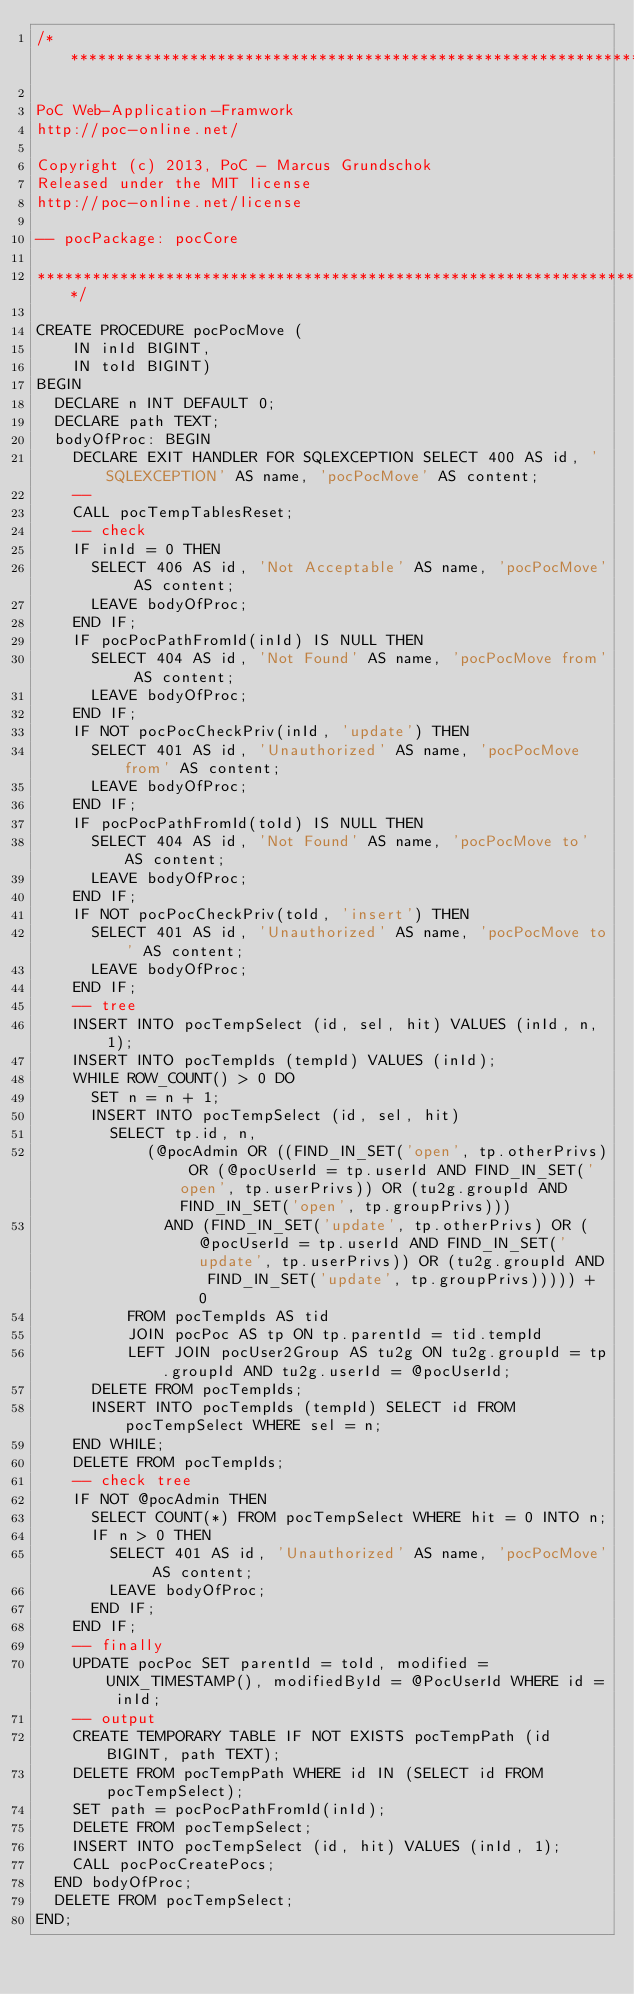Convert code to text. <code><loc_0><loc_0><loc_500><loc_500><_SQL_>/*******************************************************************************

PoC Web-Application-Framwork
http://poc-online.net/

Copyright (c) 2013, PoC - Marcus Grundschok
Released under the MIT license
http://poc-online.net/license

-- pocPackage: pocCore

*******************************************************************************/

CREATE PROCEDURE pocPocMove (
    IN inId BIGINT,
    IN toId BIGINT)
BEGIN
  DECLARE n INT DEFAULT 0;
  DECLARE path TEXT;
  bodyOfProc: BEGIN
    DECLARE EXIT HANDLER FOR SQLEXCEPTION SELECT 400 AS id, 'SQLEXCEPTION' AS name, 'pocPocMove' AS content;
    --
    CALL pocTempTablesReset;
    -- check
    IF inId = 0 THEN
      SELECT 406 AS id, 'Not Acceptable' AS name, 'pocPocMove' AS content;
      LEAVE bodyOfProc;
    END IF;
    IF pocPocPathFromId(inId) IS NULL THEN
      SELECT 404 AS id, 'Not Found' AS name, 'pocPocMove from' AS content;
      LEAVE bodyOfProc;
    END IF;
    IF NOT pocPocCheckPriv(inId, 'update') THEN
      SELECT 401 AS id, 'Unauthorized' AS name, 'pocPocMove from' AS content;
      LEAVE bodyOfProc;
    END IF;
    IF pocPocPathFromId(toId) IS NULL THEN
      SELECT 404 AS id, 'Not Found' AS name, 'pocPocMove to' AS content;
      LEAVE bodyOfProc;
    END IF;
    IF NOT pocPocCheckPriv(toId, 'insert') THEN
      SELECT 401 AS id, 'Unauthorized' AS name, 'pocPocMove to' AS content;
      LEAVE bodyOfProc;
    END IF;
    -- tree
    INSERT INTO pocTempSelect (id, sel, hit) VALUES (inId, n, 1);
    INSERT INTO pocTempIds (tempId) VALUES (inId);
    WHILE ROW_COUNT() > 0 DO
      SET n = n + 1;
      INSERT INTO pocTempSelect (id, sel, hit)
        SELECT tp.id, n,
            (@pocAdmin OR ((FIND_IN_SET('open', tp.otherPrivs) OR (@pocUserId = tp.userId AND FIND_IN_SET('open', tp.userPrivs)) OR (tu2g.groupId AND FIND_IN_SET('open', tp.groupPrivs)))
              AND (FIND_IN_SET('update', tp.otherPrivs) OR (@pocUserId = tp.userId AND FIND_IN_SET('update', tp.userPrivs)) OR (tu2g.groupId AND FIND_IN_SET('update', tp.groupPrivs))))) + 0
          FROM pocTempIds AS tid
          JOIN pocPoc AS tp ON tp.parentId = tid.tempId
          LEFT JOIN pocUser2Group AS tu2g ON tu2g.groupId = tp.groupId AND tu2g.userId = @pocUserId;
      DELETE FROM pocTempIds;
      INSERT INTO pocTempIds (tempId) SELECT id FROM pocTempSelect WHERE sel = n;
    END WHILE;
    DELETE FROM pocTempIds;
    -- check tree
    IF NOT @pocAdmin THEN
      SELECT COUNT(*) FROM pocTempSelect WHERE hit = 0 INTO n;
      IF n > 0 THEN
        SELECT 401 AS id, 'Unauthorized' AS name, 'pocPocMove' AS content;
        LEAVE bodyOfProc;
      END IF;
    END IF;
    -- finally
    UPDATE pocPoc SET parentId = toId, modified = UNIX_TIMESTAMP(), modifiedById = @PocUserId WHERE id = inId;
    -- output
    CREATE TEMPORARY TABLE IF NOT EXISTS pocTempPath (id BIGINT, path TEXT);
    DELETE FROM pocTempPath WHERE id IN (SELECT id FROM pocTempSelect);
    SET path = pocPocPathFromId(inId);
    DELETE FROM pocTempSelect;
    INSERT INTO pocTempSelect (id, hit) VALUES (inId, 1);
    CALL pocPocCreatePocs;
  END bodyOfProc;
  DELETE FROM pocTempSelect;
END;
</code> 